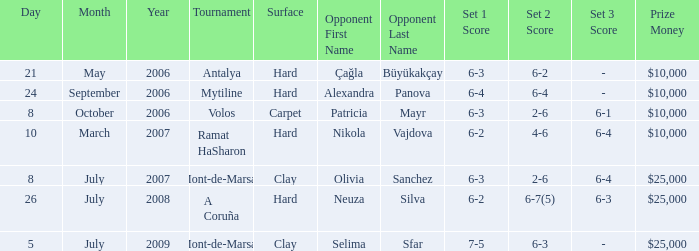What is the score of the hard court Ramat Hasharon tournament? 6-2 4-6 6-4. Can you give me this table as a dict? {'header': ['Day', 'Month', 'Year', 'Tournament', 'Surface', 'Opponent First Name', 'Opponent Last Name', 'Set 1 Score', 'Set 2 Score', 'Set 3 Score', 'Prize Money'], 'rows': [['21', 'May', '2006', 'Antalya', 'Hard', 'Çağla', 'Büyükakçay', '6-3', '6-2', '-', '$10,000'], ['24', 'September', '2006', 'Mytiline', 'Hard', 'Alexandra', 'Panova', '6-4', '6-4', '-', '$10,000'], ['8', 'October', '2006', 'Volos', 'Carpet', 'Patricia', 'Mayr', '6-3', '2-6', '6-1', '$10,000'], ['10', 'March', '2007', 'Ramat HaSharon', 'Hard', 'Nikola', 'Vajdova', '6-2', '4-6', '6-4', '$10,000'], ['8', 'July', '2007', 'Mont-de-Marsan', 'Clay', 'Olivia', 'Sanchez', '6-3', '2-6', '6-4', '$25,000'], ['26', 'July', '2008', 'A Coruña', 'Hard', 'Neuza', 'Silva', '6-2', '6-7(5)', '6-3', '$25,000'], ['5', 'July', '2009', 'Mont-de-Marsan', 'Clay', 'Selima', 'Sfar', '7-5', '6-3', '-', '$25,000']]} 